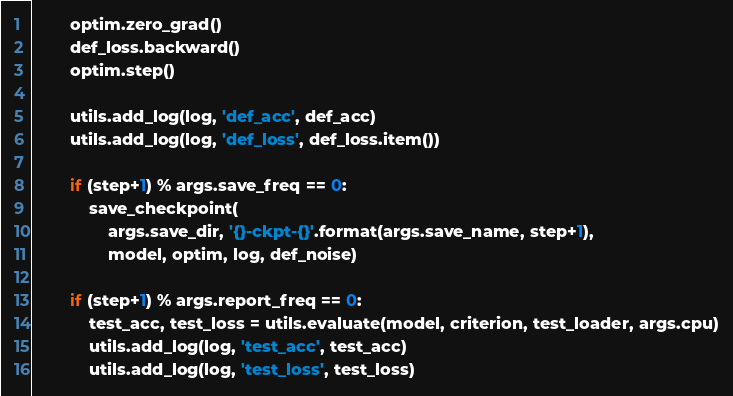<code> <loc_0><loc_0><loc_500><loc_500><_Python_>        optim.zero_grad()
        def_loss.backward()
        optim.step()

        utils.add_log(log, 'def_acc', def_acc)
        utils.add_log(log, 'def_loss', def_loss.item())

        if (step+1) % args.save_freq == 0:
            save_checkpoint(
                args.save_dir, '{}-ckpt-{}'.format(args.save_name, step+1),
                model, optim, log, def_noise)

        if (step+1) % args.report_freq == 0:
            test_acc, test_loss = utils.evaluate(model, criterion, test_loader, args.cpu)
            utils.add_log(log, 'test_acc', test_acc)
            utils.add_log(log, 'test_loss', test_loss)
</code> 